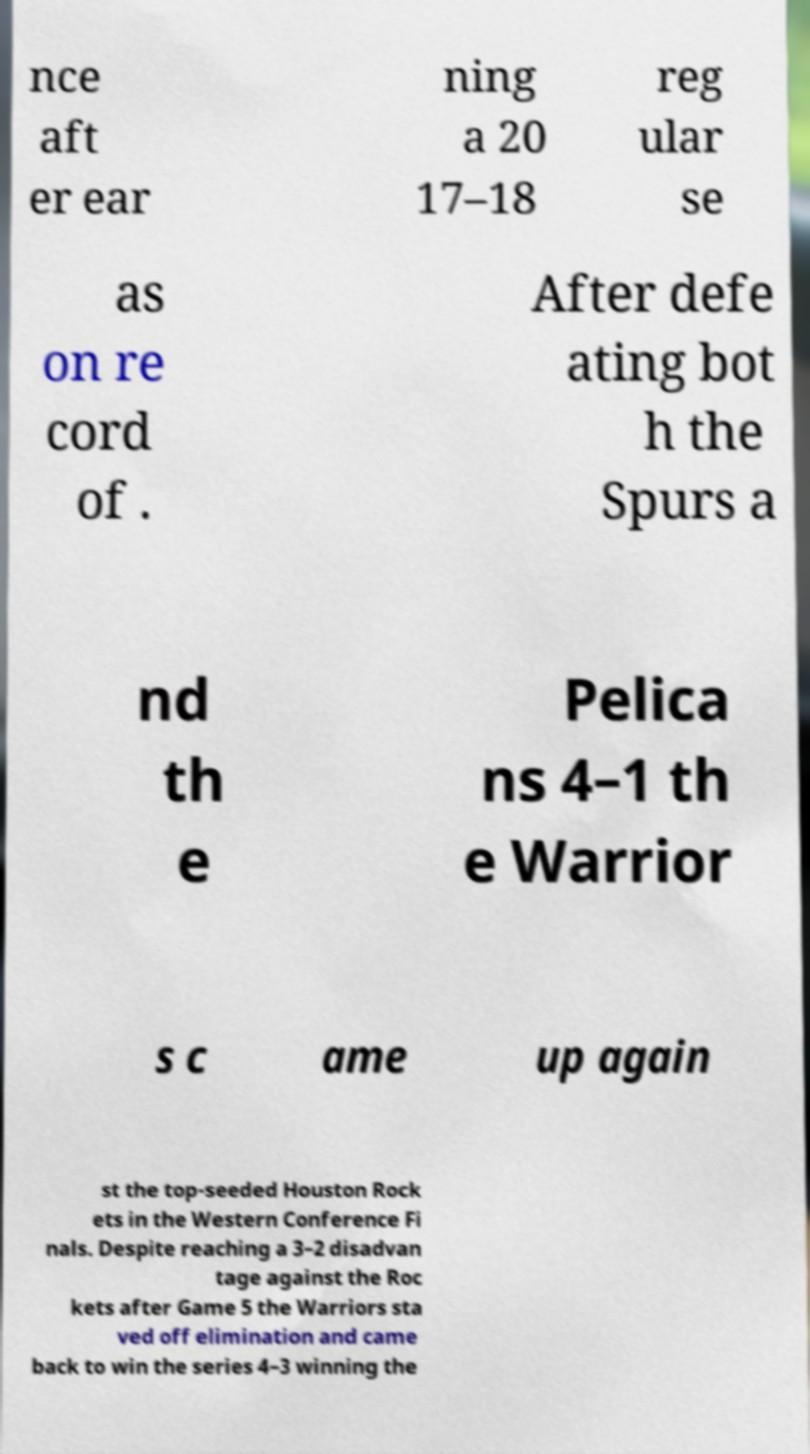For documentation purposes, I need the text within this image transcribed. Could you provide that? nce aft er ear ning a 20 17–18 reg ular se as on re cord of . After defe ating bot h the Spurs a nd th e Pelica ns 4–1 th e Warrior s c ame up again st the top-seeded Houston Rock ets in the Western Conference Fi nals. Despite reaching a 3–2 disadvan tage against the Roc kets after Game 5 the Warriors sta ved off elimination and came back to win the series 4–3 winning the 